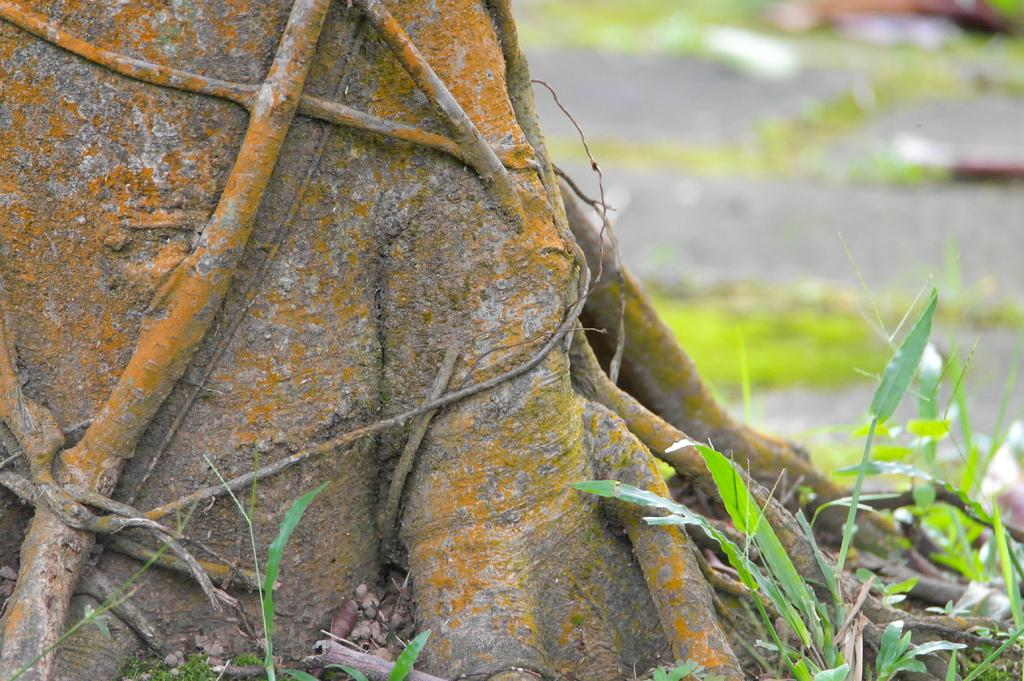What is located in the front of the image? There is a plant in the front of the image. What can be seen on the left side of the image? There are roots of a tree on the left side of the image. How would you describe the background of the image? The background of the image is blurry. Can you tell me how many members are in the band visible in the image? There is no band present in the image; it features a plant and tree roots. What type of butter is being used to water the plant in the image? There is no butter present in the image; it features a plant and tree roots. 